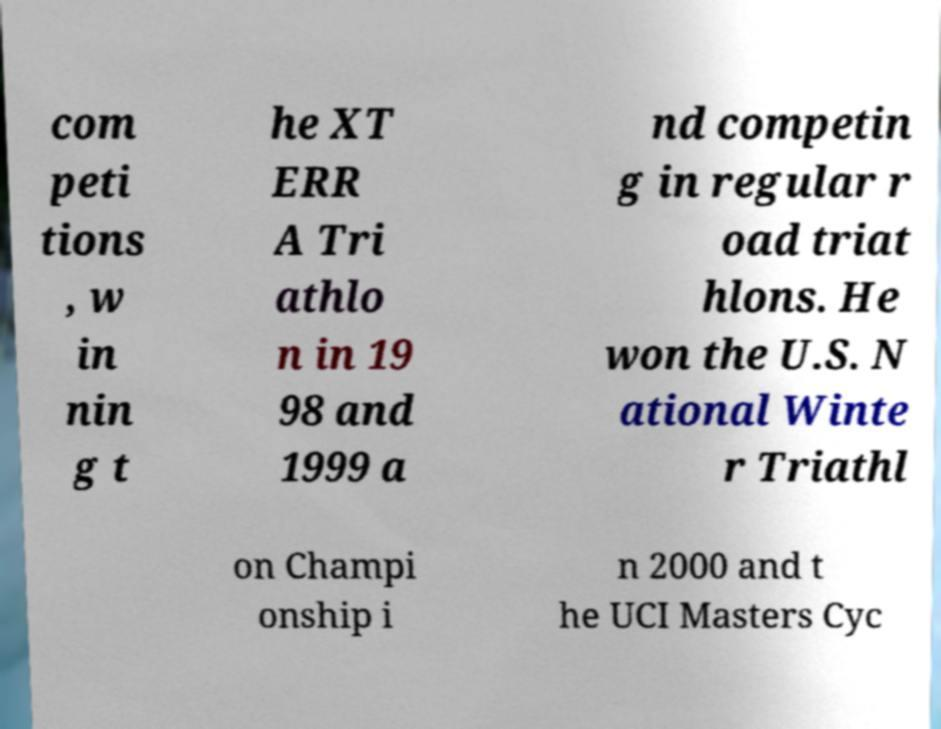What messages or text are displayed in this image? I need them in a readable, typed format. com peti tions , w in nin g t he XT ERR A Tri athlo n in 19 98 and 1999 a nd competin g in regular r oad triat hlons. He won the U.S. N ational Winte r Triathl on Champi onship i n 2000 and t he UCI Masters Cyc 